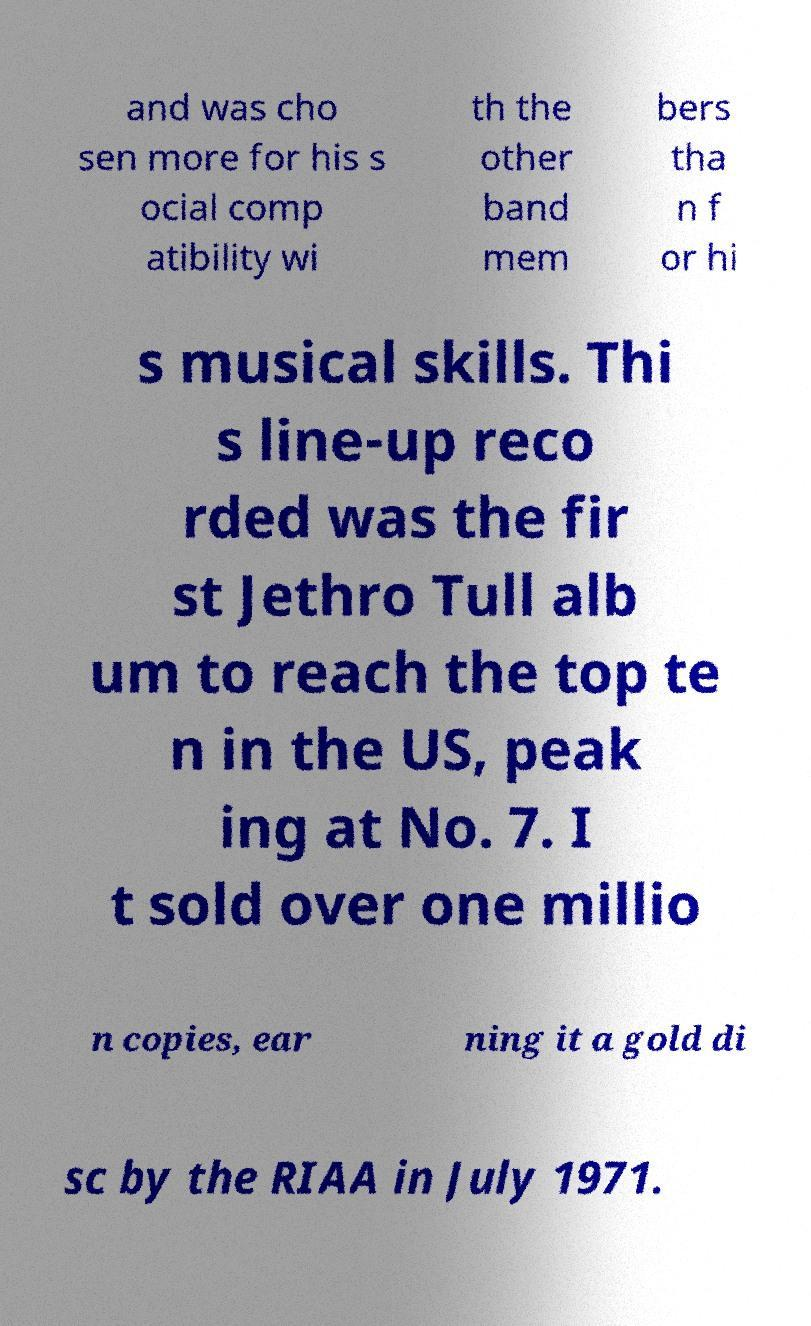There's text embedded in this image that I need extracted. Can you transcribe it verbatim? and was cho sen more for his s ocial comp atibility wi th the other band mem bers tha n f or hi s musical skills. Thi s line-up reco rded was the fir st Jethro Tull alb um to reach the top te n in the US, peak ing at No. 7. I t sold over one millio n copies, ear ning it a gold di sc by the RIAA in July 1971. 